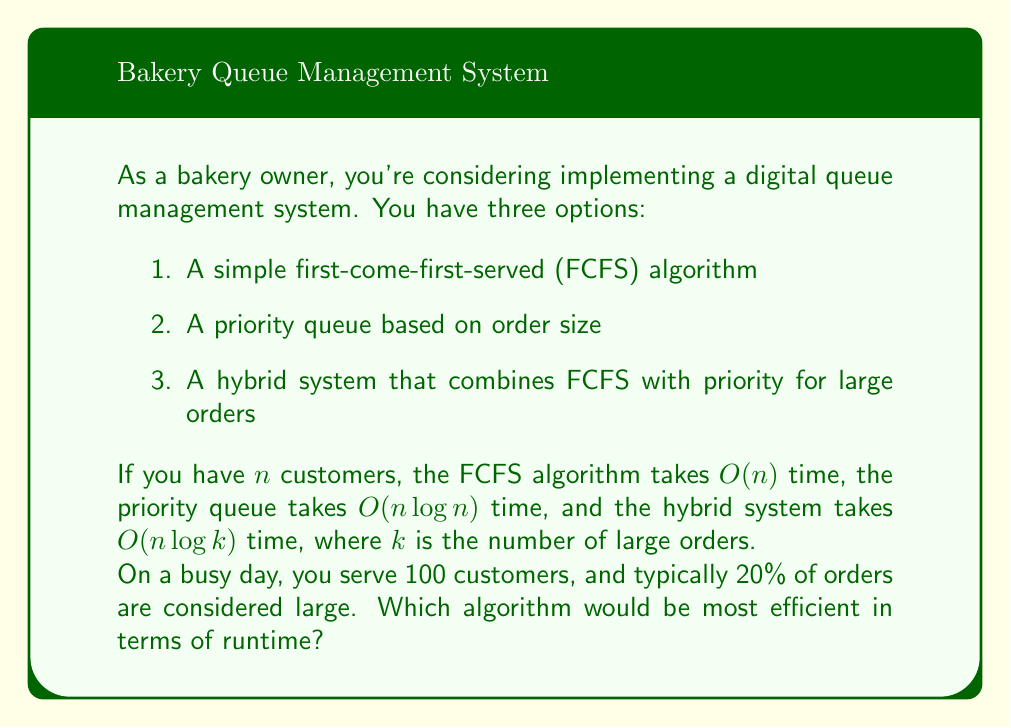Provide a solution to this math problem. Let's analyze each algorithm:

1. FCFS algorithm:
   Runtime: $O(n)$
   With $n = 100$, the runtime is proportional to 100.

2. Priority queue:
   Runtime: $O(n \log n)$
   With $n = 100$, the runtime is proportional to $100 \log 100 \approx 200$.

3. Hybrid system:
   Runtime: $O(n \log k)$
   Where $k$ is the number of large orders.
   $k = 20\% \text{ of } n = 0.2 \times 100 = 20$
   The runtime is proportional to $100 \log 20 \approx 130$.

To compare these, let's consider their relative efficiencies:

$$\frac{O(n)}{O(n \log n)} < \frac{O(n)}{O(n \log k)} < \frac{O(n \log k)}{O(n \log n)}$$

This shows that $O(n)$ is the most efficient, followed by $O(n \log k)$, and then $O(n \log n)$.

Therefore, the FCFS algorithm (option 1) would be the most efficient in terms of runtime.
Answer: The simple first-come-first-served (FCFS) algorithm with $O(n)$ runtime would be the most efficient in terms of runtime. 